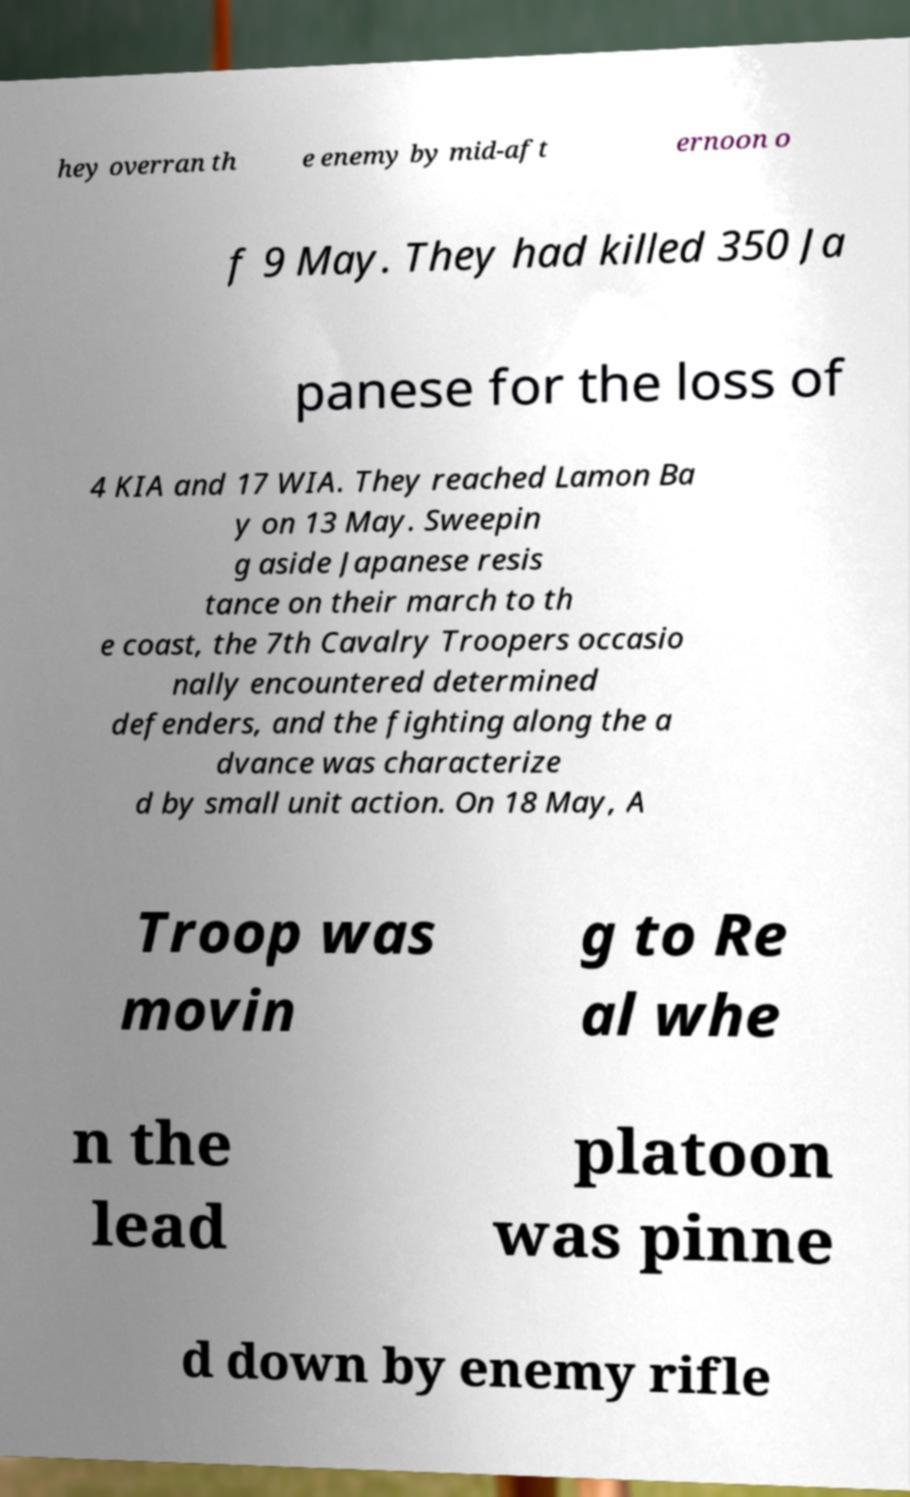I need the written content from this picture converted into text. Can you do that? hey overran th e enemy by mid-aft ernoon o f 9 May. They had killed 350 Ja panese for the loss of 4 KIA and 17 WIA. They reached Lamon Ba y on 13 May. Sweepin g aside Japanese resis tance on their march to th e coast, the 7th Cavalry Troopers occasio nally encountered determined defenders, and the fighting along the a dvance was characterize d by small unit action. On 18 May, A Troop was movin g to Re al whe n the lead platoon was pinne d down by enemy rifle 